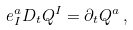Convert formula to latex. <formula><loc_0><loc_0><loc_500><loc_500>e _ { I } ^ { a } D _ { t } Q ^ { I } = \partial _ { t } Q ^ { a } \, ,</formula> 